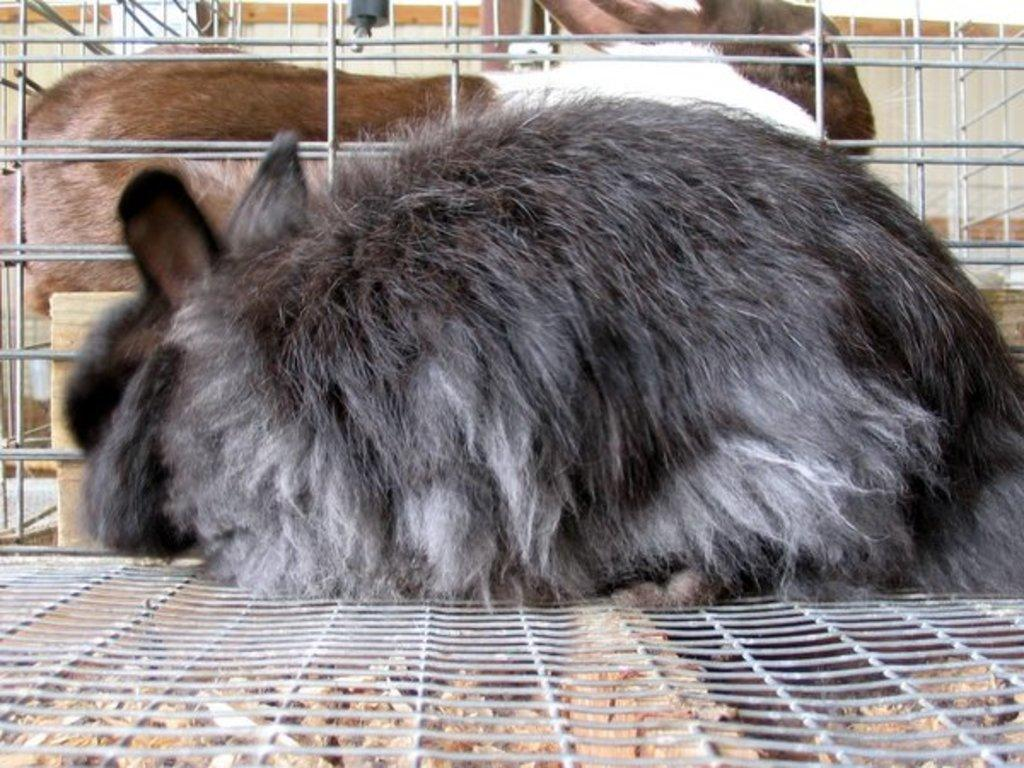What type of animals are in the image? There are rabbits in the image. Where are the rabbits located? The rabbits are in a cage. What type of apple is hanging from the moon in the image? There is no apple or moon present in the image; it features rabbits in a cage. 